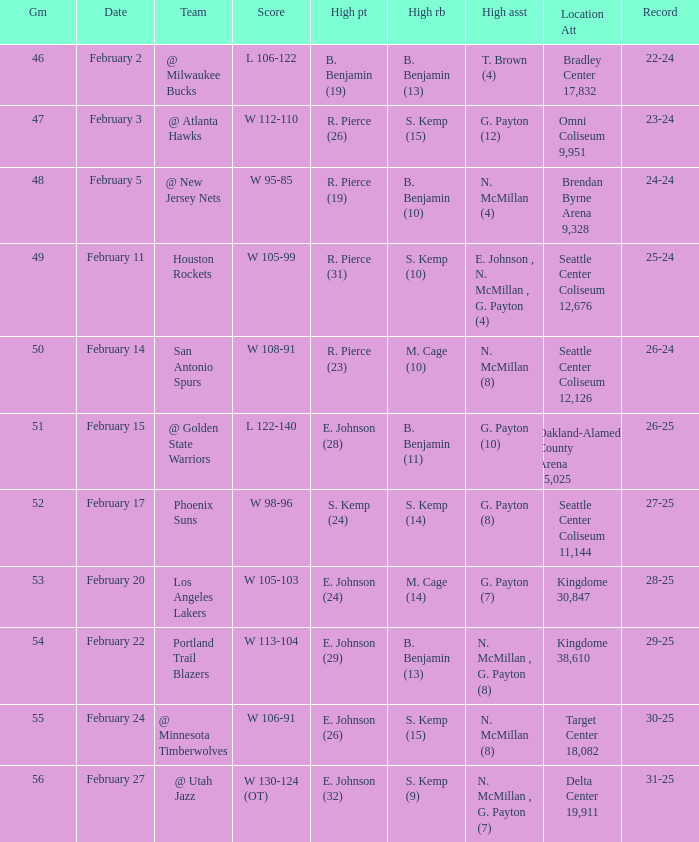Who had the high points when the score was w 112-110? R. Pierce (26). 